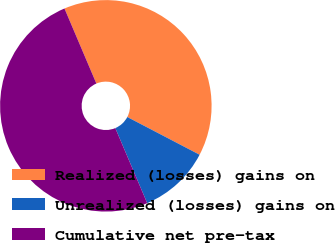Convert chart. <chart><loc_0><loc_0><loc_500><loc_500><pie_chart><fcel>Realized (losses) gains on<fcel>Unrealized (losses) gains on<fcel>Cumulative net pre-tax<nl><fcel>39.05%<fcel>10.95%<fcel>50.0%<nl></chart> 